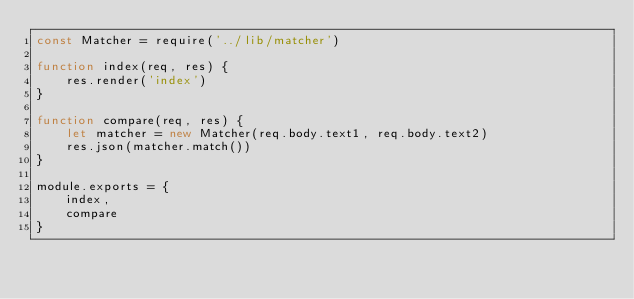Convert code to text. <code><loc_0><loc_0><loc_500><loc_500><_JavaScript_>const Matcher = require('../lib/matcher')

function index(req, res) {
    res.render('index')
}

function compare(req, res) {
    let matcher = new Matcher(req.body.text1, req.body.text2)
    res.json(matcher.match())
}

module.exports = {
    index,
    compare
}</code> 